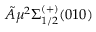Convert formula to latex. <formula><loc_0><loc_0><loc_500><loc_500>\tilde { A } ^ { 2 } \Sigma _ { 1 / 2 } ^ { ( + ) } ( 0 1 0 )</formula> 